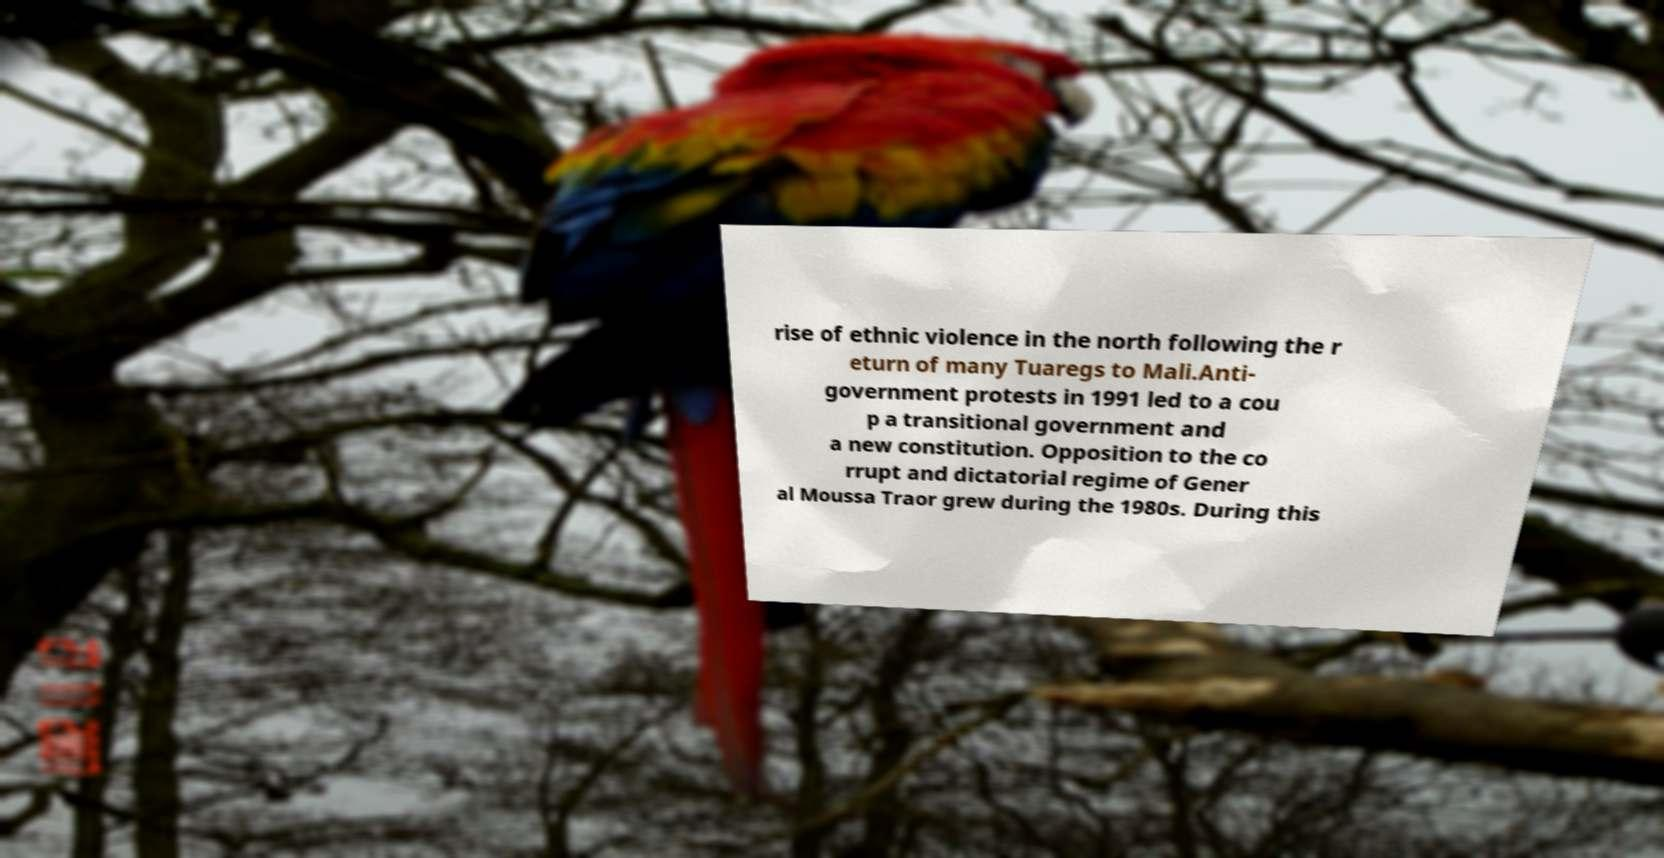Can you accurately transcribe the text from the provided image for me? rise of ethnic violence in the north following the r eturn of many Tuaregs to Mali.Anti- government protests in 1991 led to a cou p a transitional government and a new constitution. Opposition to the co rrupt and dictatorial regime of Gener al Moussa Traor grew during the 1980s. During this 